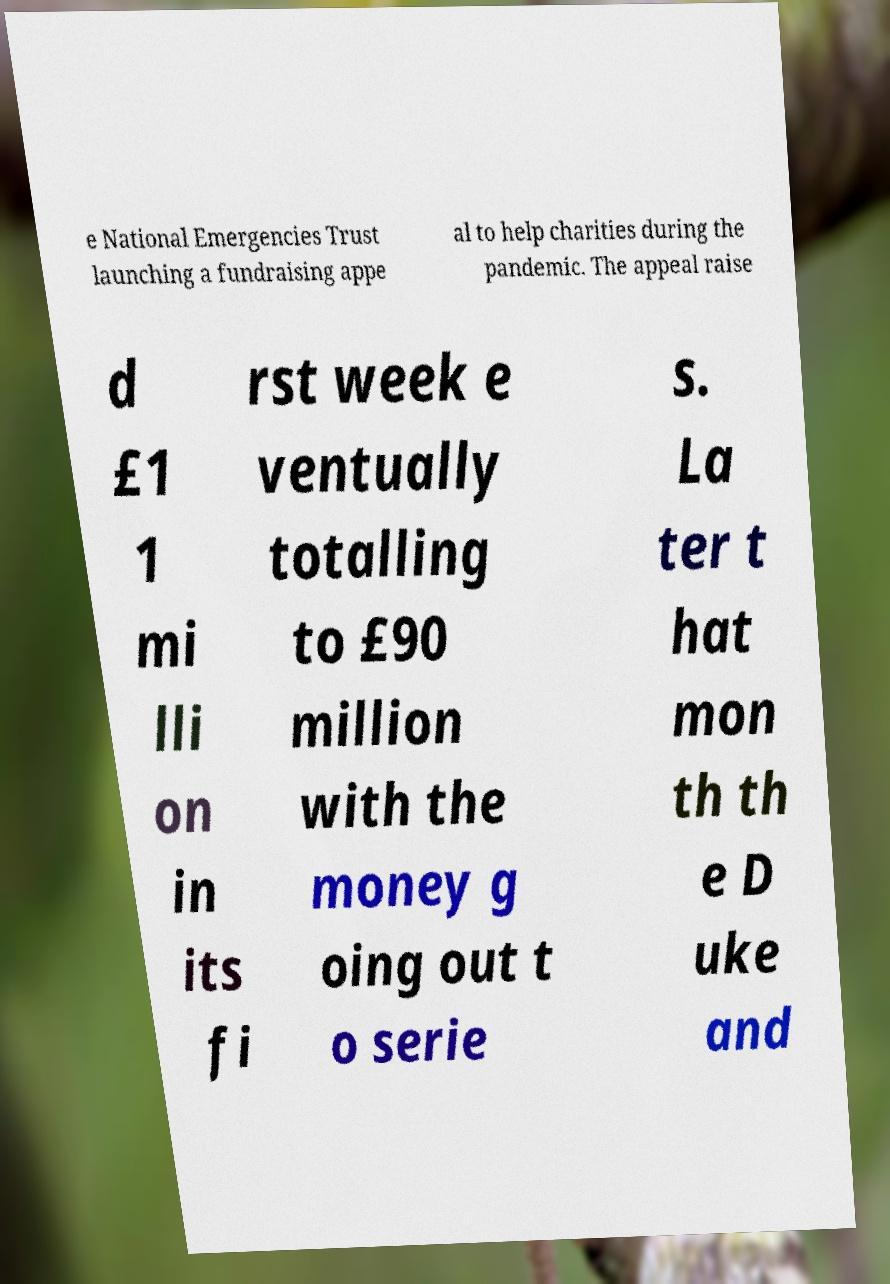Please read and relay the text visible in this image. What does it say? e National Emergencies Trust launching a fundraising appe al to help charities during the pandemic. The appeal raise d £1 1 mi lli on in its fi rst week e ventually totalling to £90 million with the money g oing out t o serie s. La ter t hat mon th th e D uke and 